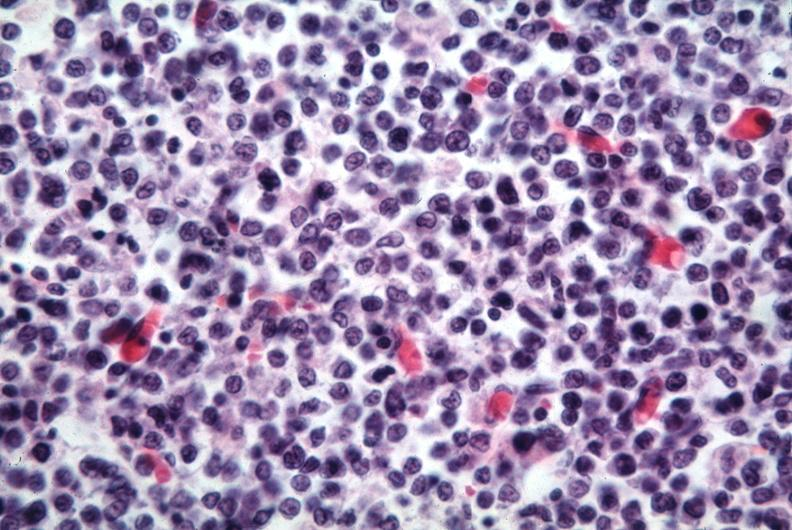s lymphoblastic lymphoma present?
Answer the question using a single word or phrase. Yes 